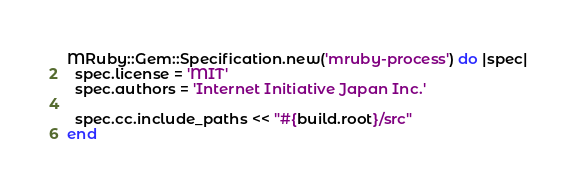Convert code to text. <code><loc_0><loc_0><loc_500><loc_500><_Ruby_>MRuby::Gem::Specification.new('mruby-process') do |spec|
  spec.license = 'MIT'
  spec.authors = 'Internet Initiative Japan Inc.'

  spec.cc.include_paths << "#{build.root}/src"
end
</code> 